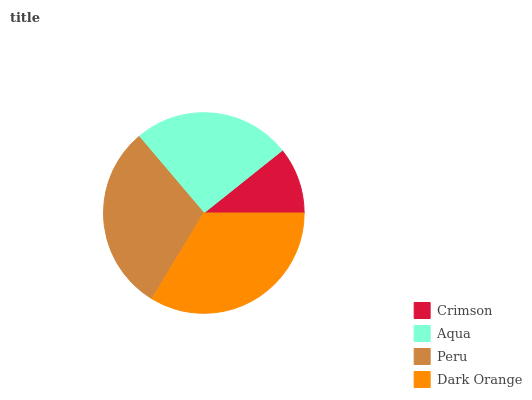Is Crimson the minimum?
Answer yes or no. Yes. Is Dark Orange the maximum?
Answer yes or no. Yes. Is Aqua the minimum?
Answer yes or no. No. Is Aqua the maximum?
Answer yes or no. No. Is Aqua greater than Crimson?
Answer yes or no. Yes. Is Crimson less than Aqua?
Answer yes or no. Yes. Is Crimson greater than Aqua?
Answer yes or no. No. Is Aqua less than Crimson?
Answer yes or no. No. Is Peru the high median?
Answer yes or no. Yes. Is Aqua the low median?
Answer yes or no. Yes. Is Aqua the high median?
Answer yes or no. No. Is Dark Orange the low median?
Answer yes or no. No. 